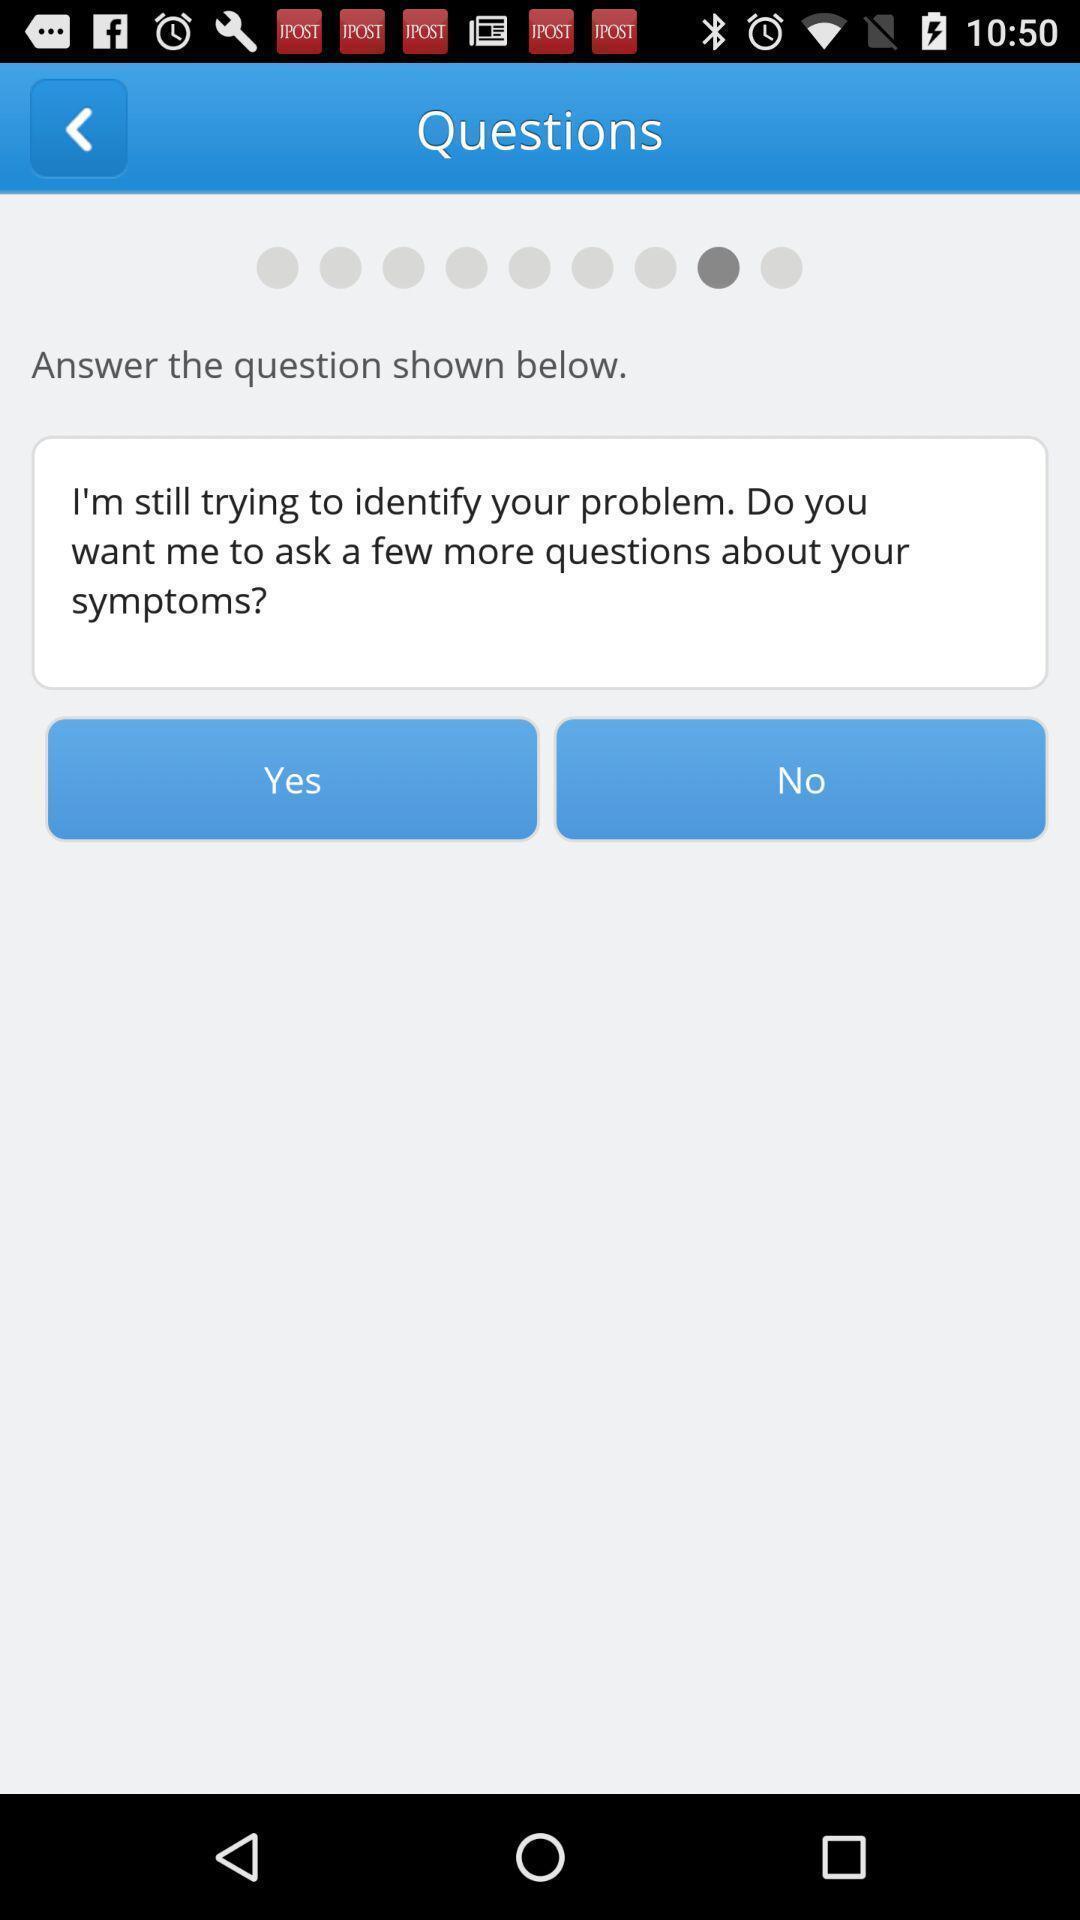Summarize the main components in this picture. Screen page of a health application. 